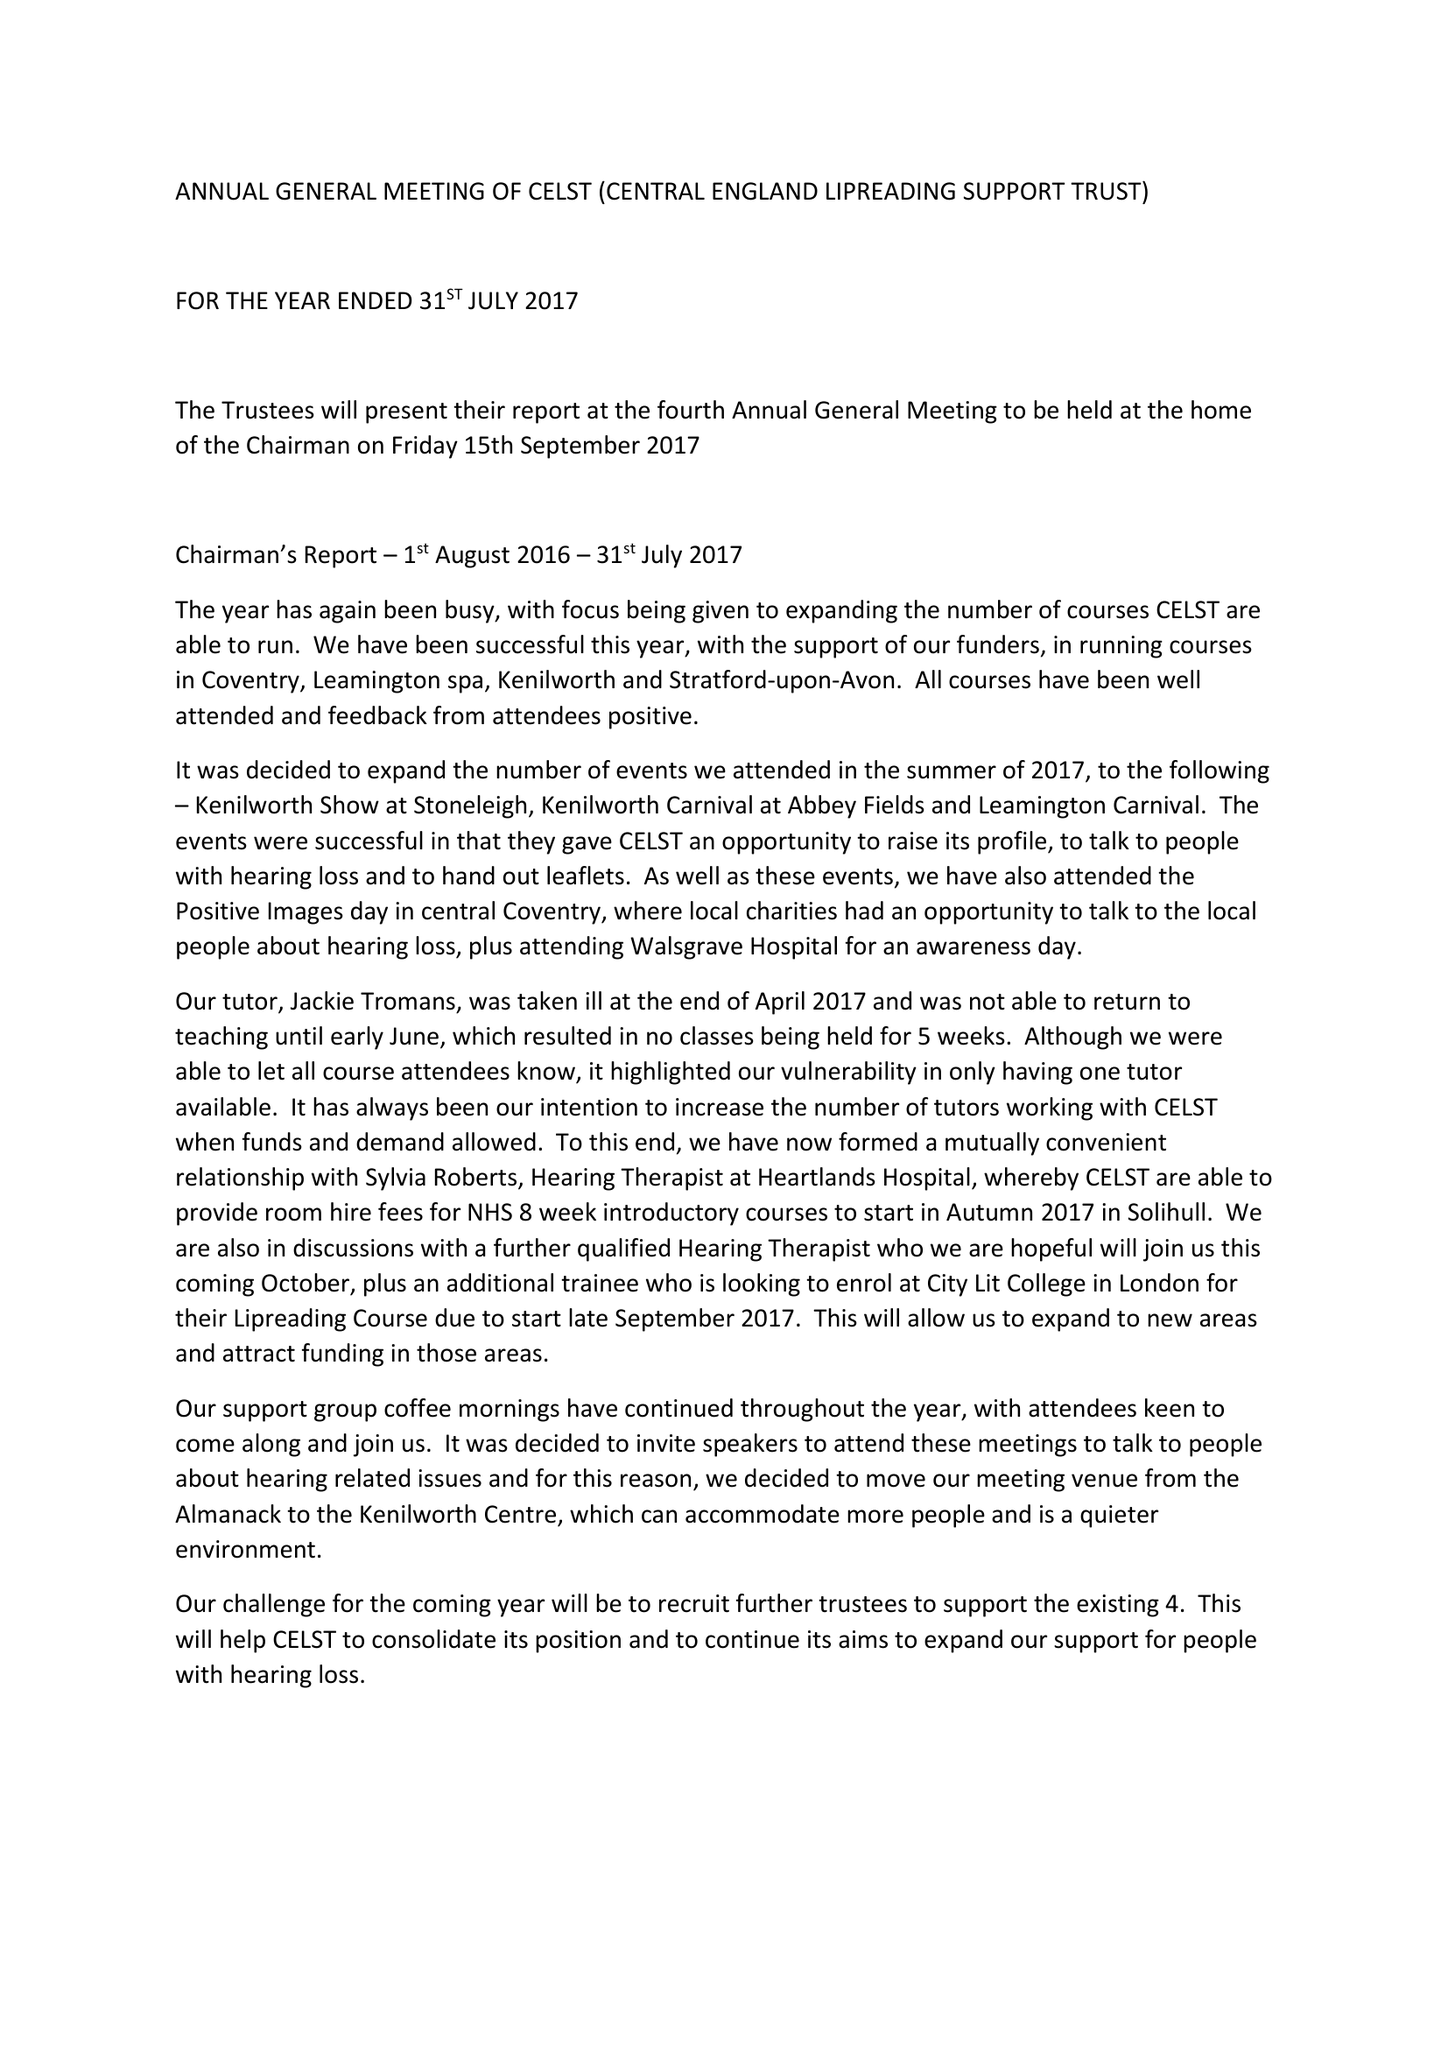What is the value for the address__post_town?
Answer the question using a single word or phrase. KENILWORTH 